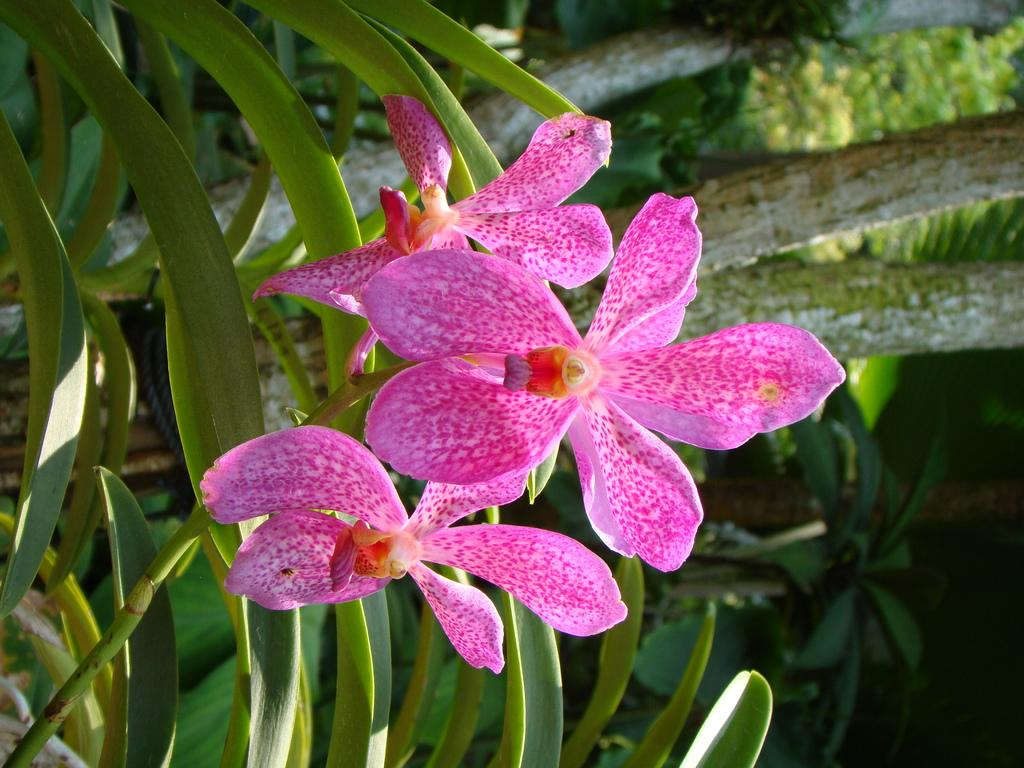What is the main subject of the image? The main subject of the image is a stem with flowers. Can you describe the flowers on the stem? Unfortunately, the facts provided do not give any details about the flowers on the stem. What can be seen in the background of the image? In the background of the image, there are plants with leaves. How does the soap exchange hands in the image? There is no soap present in the image, so it cannot be exchanged. 